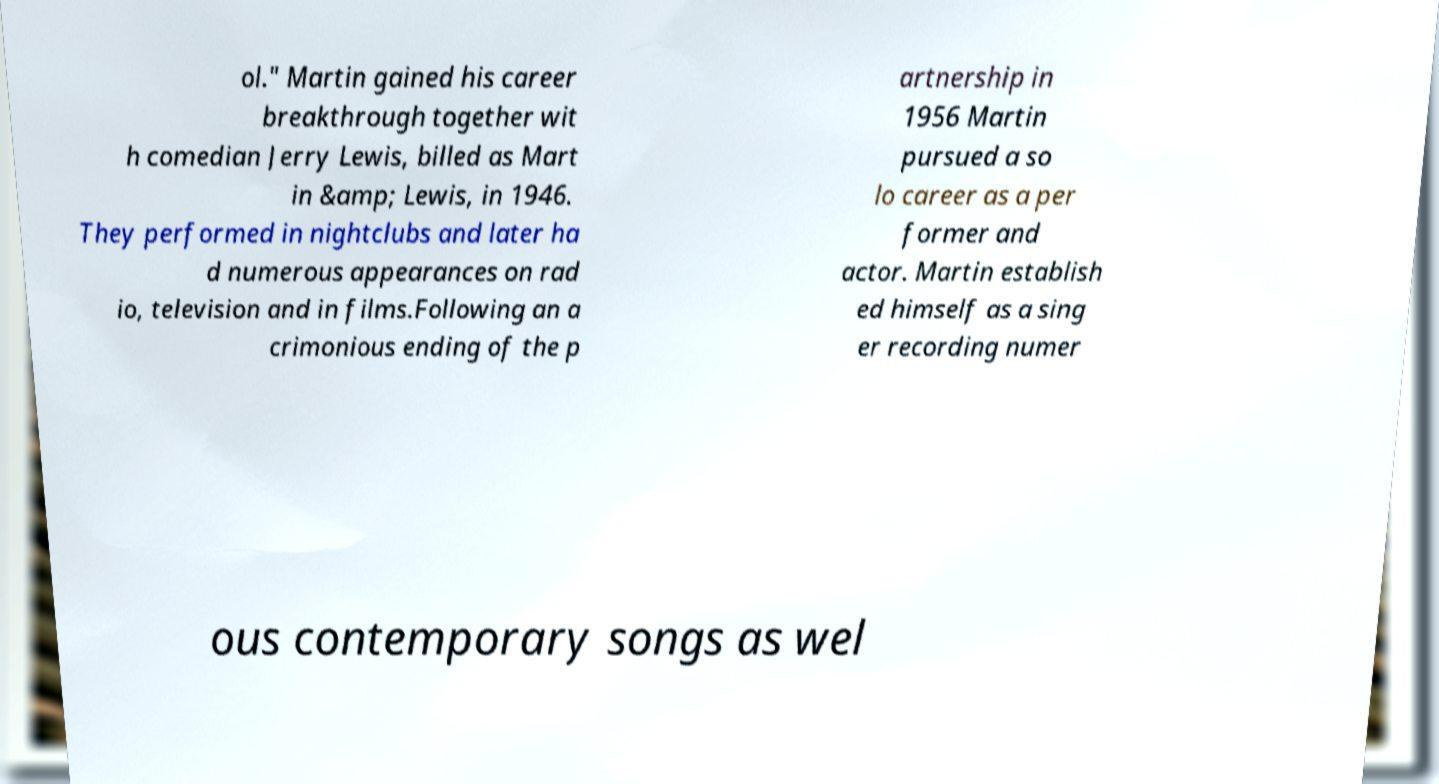There's text embedded in this image that I need extracted. Can you transcribe it verbatim? ol." Martin gained his career breakthrough together wit h comedian Jerry Lewis, billed as Mart in &amp; Lewis, in 1946. They performed in nightclubs and later ha d numerous appearances on rad io, television and in films.Following an a crimonious ending of the p artnership in 1956 Martin pursued a so lo career as a per former and actor. Martin establish ed himself as a sing er recording numer ous contemporary songs as wel 